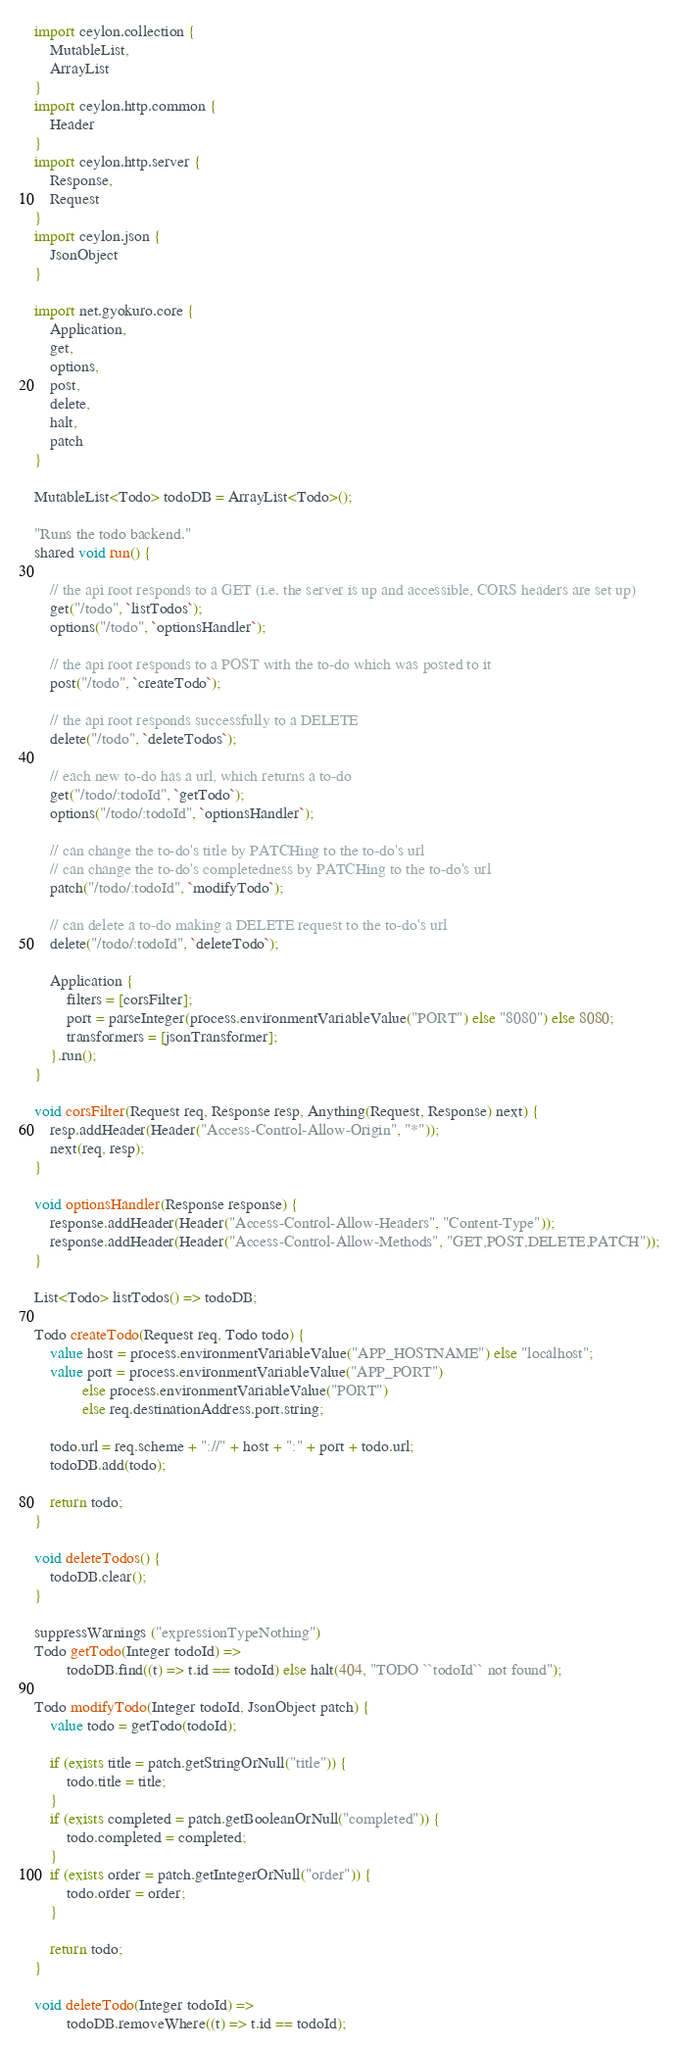Convert code to text. <code><loc_0><loc_0><loc_500><loc_500><_Ceylon_>import ceylon.collection {
    MutableList,
    ArrayList
}
import ceylon.http.common {
    Header
}
import ceylon.http.server {
    Response,
    Request
}
import ceylon.json {
    JsonObject
}

import net.gyokuro.core {
    Application,
    get,
    options,
    post,
    delete,
    halt,
    patch
}

MutableList<Todo> todoDB = ArrayList<Todo>();

"Runs the todo backend."
shared void run() {

    // the api root responds to a GET (i.e. the server is up and accessible, CORS headers are set up)
    get("/todo", `listTodos`);
    options("/todo", `optionsHandler`);

    // the api root responds to a POST with the to-do which was posted to it
    post("/todo", `createTodo`);

    // the api root responds successfully to a DELETE
    delete("/todo", `deleteTodos`);

    // each new to-do has a url, which returns a to-do
    get("/todo/:todoId", `getTodo`);
    options("/todo/:todoId", `optionsHandler`);

    // can change the to-do's title by PATCHing to the to-do's url
    // can change the to-do's completedness by PATCHing to the to-do's url
    patch("/todo/:todoId", `modifyTodo`);

    // can delete a to-do making a DELETE request to the to-do's url
    delete("/todo/:todoId", `deleteTodo`);

    Application {
        filters = [corsFilter];
        port = parseInteger(process.environmentVariableValue("PORT") else "8080") else 8080;
        transformers = [jsonTransformer];
    }.run();
}

void corsFilter(Request req, Response resp, Anything(Request, Response) next) {
    resp.addHeader(Header("Access-Control-Allow-Origin", "*"));
    next(req, resp);
}

void optionsHandler(Response response) {
    response.addHeader(Header("Access-Control-Allow-Headers", "Content-Type"));
    response.addHeader(Header("Access-Control-Allow-Methods", "GET,POST,DELETE,PATCH"));
}

List<Todo> listTodos() => todoDB;

Todo createTodo(Request req, Todo todo) {
    value host = process.environmentVariableValue("APP_HOSTNAME") else "localhost";
    value port = process.environmentVariableValue("APP_PORT")
            else process.environmentVariableValue("PORT")
            else req.destinationAddress.port.string;

    todo.url = req.scheme + "://" + host + ":" + port + todo.url;
    todoDB.add(todo);

    return todo;
}

void deleteTodos() {
    todoDB.clear();
}

suppressWarnings ("expressionTypeNothing")
Todo getTodo(Integer todoId) =>
        todoDB.find((t) => t.id == todoId) else halt(404, "TODO ``todoId`` not found");

Todo modifyTodo(Integer todoId, JsonObject patch) {
    value todo = getTodo(todoId);

    if (exists title = patch.getStringOrNull("title")) {
        todo.title = title;
    }
    if (exists completed = patch.getBooleanOrNull("completed")) {
        todo.completed = completed;
    }
    if (exists order = patch.getIntegerOrNull("order")) {
        todo.order = order;
    }

    return todo;
}

void deleteTodo(Integer todoId) =>
        todoDB.removeWhere((t) => t.id == todoId);
</code> 